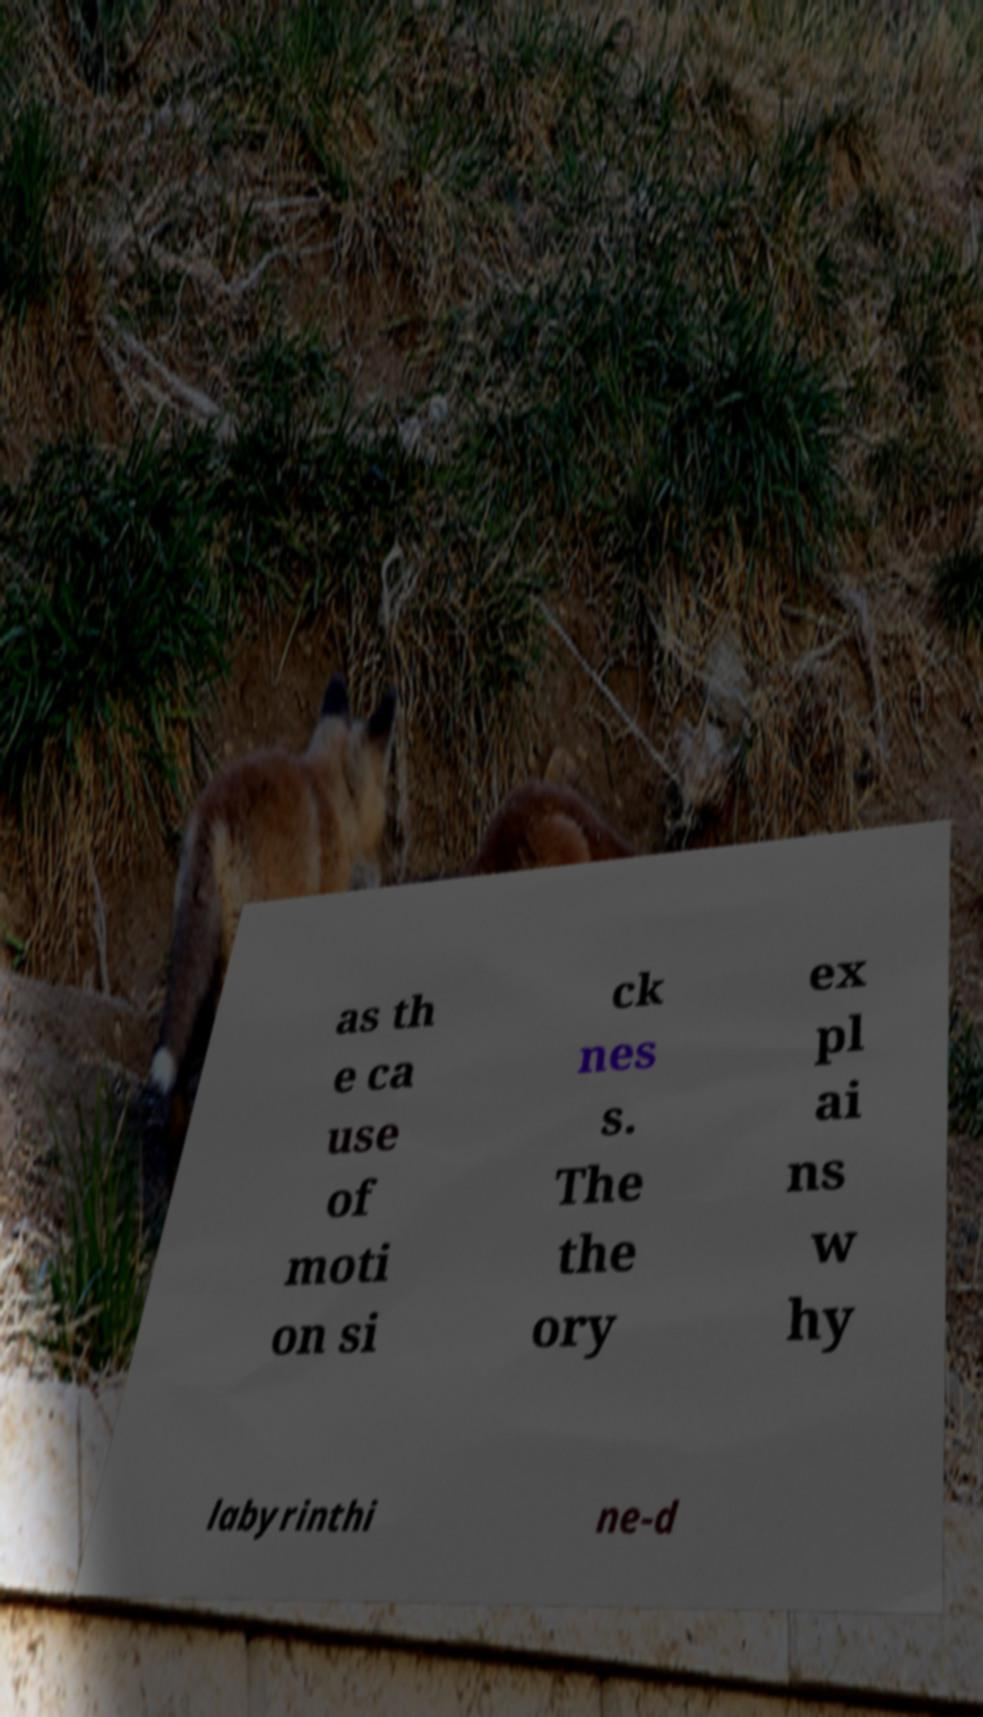Please read and relay the text visible in this image. What does it say? as th e ca use of moti on si ck nes s. The the ory ex pl ai ns w hy labyrinthi ne-d 